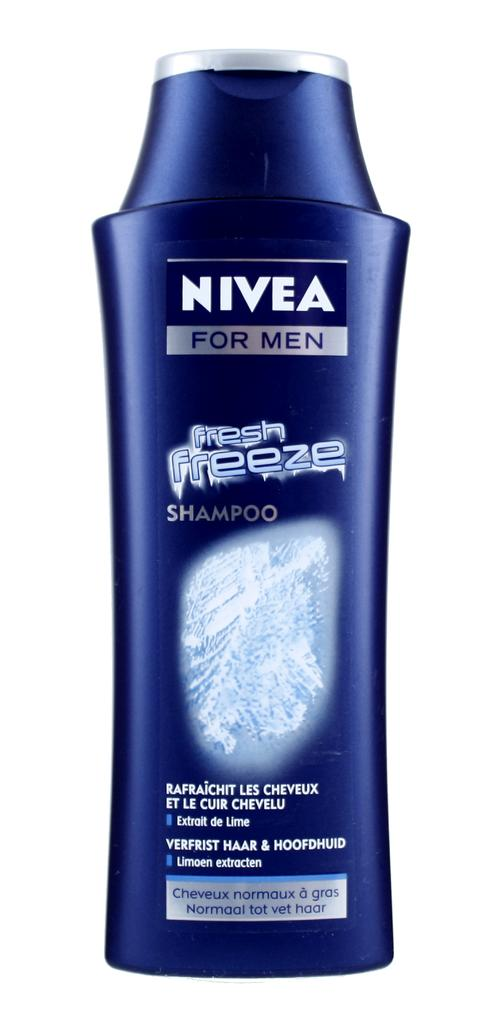<image>
Present a compact description of the photo's key features. A bottle of Nivea for men Fresh Freeze shampoo 